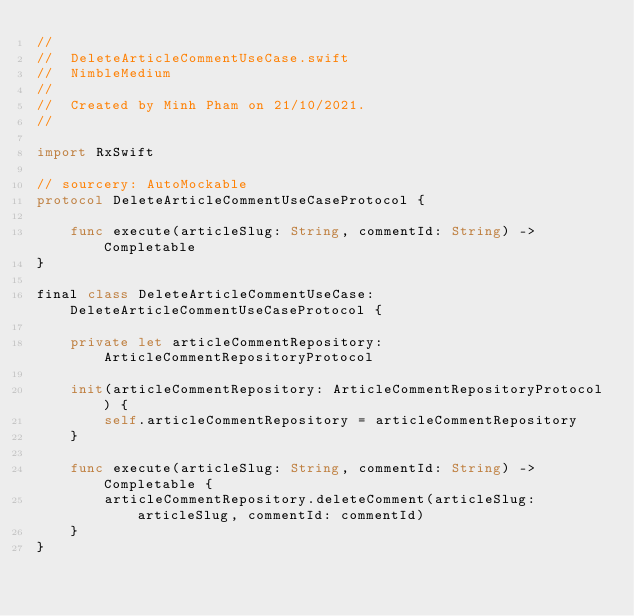<code> <loc_0><loc_0><loc_500><loc_500><_Swift_>//
//  DeleteArticleCommentUseCase.swift
//  NimbleMedium
//
//  Created by Minh Pham on 21/10/2021.
//

import RxSwift

// sourcery: AutoMockable
protocol DeleteArticleCommentUseCaseProtocol {

    func execute(articleSlug: String, commentId: String) -> Completable
}

final class DeleteArticleCommentUseCase: DeleteArticleCommentUseCaseProtocol {

    private let articleCommentRepository: ArticleCommentRepositoryProtocol

    init(articleCommentRepository: ArticleCommentRepositoryProtocol) {
        self.articleCommentRepository = articleCommentRepository
    }

    func execute(articleSlug: String, commentId: String) -> Completable {
        articleCommentRepository.deleteComment(articleSlug: articleSlug, commentId: commentId)
    }
}
</code> 